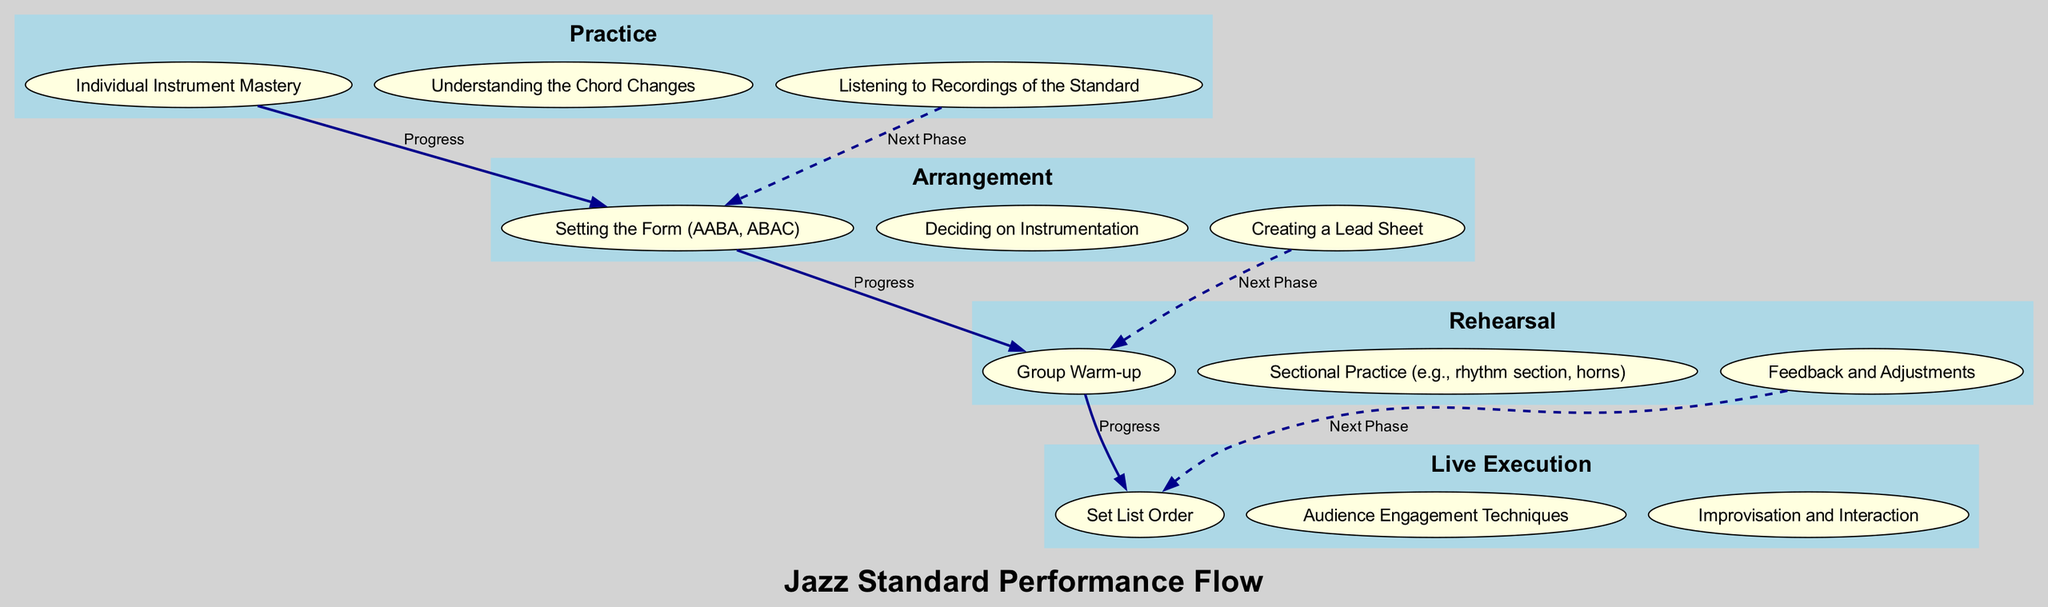What is the last stage in the performance breakdown? The last stage in the performance breakdown is Live Execution. The diagram clearly lists the stages in order from Practice to Live Execution, with Live Execution positioned at the bottom of the flow.
Answer: Live Execution How many activities are listed under the Arrangement stage? Under the Arrangement stage, there are three activities detailed: Setting the Form, Deciding on Instrumentation, and Creating a Lead Sheet. Counting these provides the answer.
Answer: 3 Which activity is the first in the Rehearsal stage? The first activity in the Rehearsal stage is Group Warm-up. By looking at the activities listed for that particular stage, Group Warm-up appears at the top.
Answer: Group Warm-up What is the relationship type between Practice and Arrangement stages? The relationship between Practice and Arrangement stages is described as "Progress." This label connects the last activity of Practice to the first activity of Arrangement in the diagram.
Answer: Progress What are the two types of connections represented in this flowchart? The diagram features two types of connections: solid lines representing "Progress" and dashed lines representing "Next Phase." Each connection type visually differentiates the flow of activities.
Answer: Progress, Next Phase How many total stages are there in the performance breakdown? There are four total stages highlighted in the performance breakdown: Practice, Arrangement, Rehearsal, and Live Execution. Counting each of these stages provides the total.
Answer: 4 What is the third activity listed in the Live Execution stage? The third activity in the Live Execution stage is Improvisation and Interaction. By visually scanning the activities under that stage, it is identified as the third item.
Answer: Improvisation and Interaction Which stage comes directly after Rehearsal in the flow? The stage that comes directly after Rehearsal is Live Execution. Following the flow of the diagram, Live Execution is positioned immediately below Rehearsal.
Answer: Live Execution What is the last activity of the Arrangement stage? The last activity of the Arrangement stage is Creating a Lead Sheet. By reviewing the list of activities for that stage, it is clear that this one appears last.
Answer: Creating a Lead Sheet 